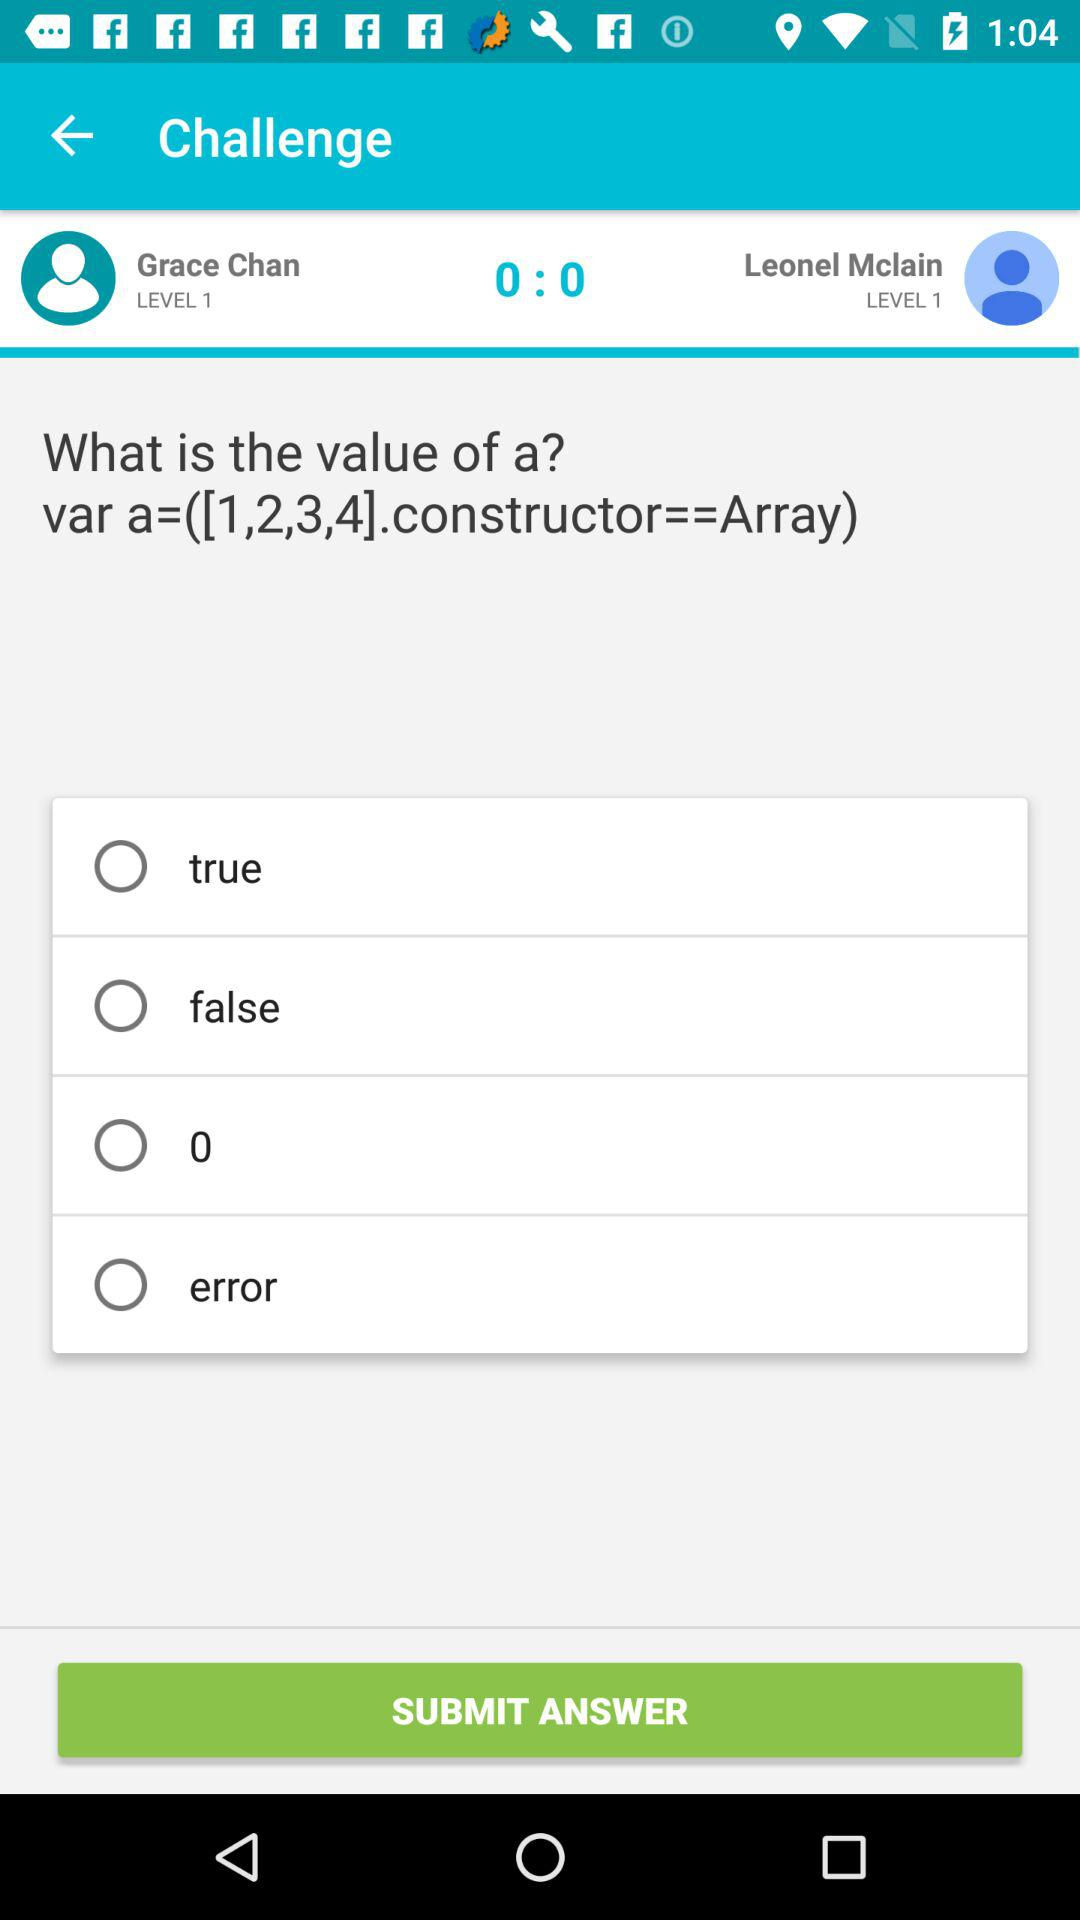At what level of challenge are Grace and Leonel? Grace and Leonel are at the level of challenge 1. 